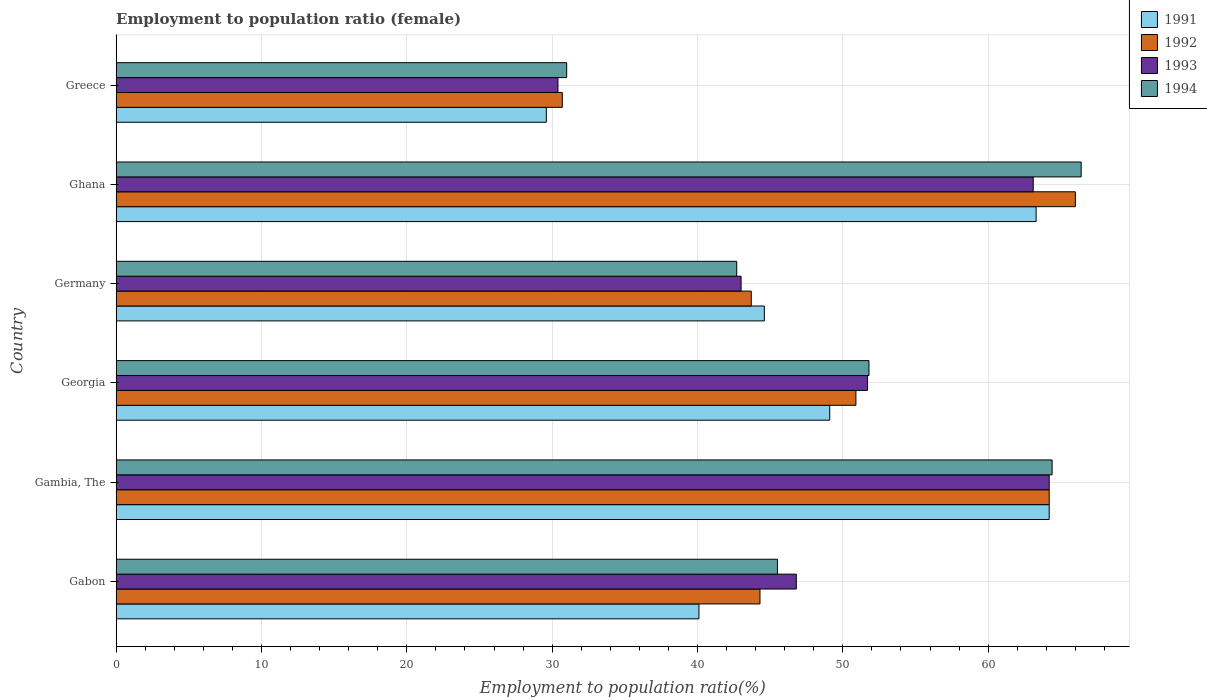How many different coloured bars are there?
Your answer should be very brief. 4. How many groups of bars are there?
Provide a short and direct response. 6. Are the number of bars per tick equal to the number of legend labels?
Your answer should be very brief. Yes. How many bars are there on the 2nd tick from the bottom?
Offer a terse response. 4. What is the label of the 5th group of bars from the top?
Give a very brief answer. Gambia, The. What is the employment to population ratio in 1994 in Georgia?
Give a very brief answer. 51.8. Across all countries, what is the maximum employment to population ratio in 1994?
Your answer should be compact. 66.4. Across all countries, what is the minimum employment to population ratio in 1993?
Your response must be concise. 30.4. In which country was the employment to population ratio in 1994 maximum?
Your answer should be very brief. Ghana. What is the total employment to population ratio in 1994 in the graph?
Offer a very short reply. 301.8. What is the difference between the employment to population ratio in 1992 in Gambia, The and that in Ghana?
Offer a terse response. -1.8. What is the difference between the employment to population ratio in 1993 in Georgia and the employment to population ratio in 1991 in Gambia, The?
Your answer should be compact. -12.5. What is the average employment to population ratio in 1993 per country?
Keep it short and to the point. 49.87. What is the difference between the employment to population ratio in 1993 and employment to population ratio in 1991 in Germany?
Your response must be concise. -1.6. In how many countries, is the employment to population ratio in 1994 greater than 14 %?
Keep it short and to the point. 6. What is the ratio of the employment to population ratio in 1993 in Gabon to that in Ghana?
Ensure brevity in your answer.  0.74. What is the difference between the highest and the second highest employment to population ratio in 1993?
Your answer should be very brief. 1.1. What is the difference between the highest and the lowest employment to population ratio in 1994?
Offer a terse response. 35.4. Is the sum of the employment to population ratio in 1994 in Gabon and Germany greater than the maximum employment to population ratio in 1991 across all countries?
Make the answer very short. Yes. What does the 2nd bar from the bottom in Gabon represents?
Keep it short and to the point. 1992. How many bars are there?
Offer a terse response. 24. Are all the bars in the graph horizontal?
Ensure brevity in your answer.  Yes. How many countries are there in the graph?
Provide a succinct answer. 6. Where does the legend appear in the graph?
Offer a very short reply. Top right. How are the legend labels stacked?
Your response must be concise. Vertical. What is the title of the graph?
Provide a succinct answer. Employment to population ratio (female). Does "1995" appear as one of the legend labels in the graph?
Ensure brevity in your answer.  No. What is the label or title of the X-axis?
Your answer should be very brief. Employment to population ratio(%). What is the Employment to population ratio(%) in 1991 in Gabon?
Give a very brief answer. 40.1. What is the Employment to population ratio(%) in 1992 in Gabon?
Make the answer very short. 44.3. What is the Employment to population ratio(%) of 1993 in Gabon?
Your answer should be compact. 46.8. What is the Employment to population ratio(%) in 1994 in Gabon?
Offer a terse response. 45.5. What is the Employment to population ratio(%) of 1991 in Gambia, The?
Your answer should be compact. 64.2. What is the Employment to population ratio(%) of 1992 in Gambia, The?
Provide a short and direct response. 64.2. What is the Employment to population ratio(%) of 1993 in Gambia, The?
Offer a very short reply. 64.2. What is the Employment to population ratio(%) in 1994 in Gambia, The?
Your answer should be compact. 64.4. What is the Employment to population ratio(%) of 1991 in Georgia?
Keep it short and to the point. 49.1. What is the Employment to population ratio(%) in 1992 in Georgia?
Provide a short and direct response. 50.9. What is the Employment to population ratio(%) of 1993 in Georgia?
Your answer should be compact. 51.7. What is the Employment to population ratio(%) in 1994 in Georgia?
Your answer should be compact. 51.8. What is the Employment to population ratio(%) of 1991 in Germany?
Offer a terse response. 44.6. What is the Employment to population ratio(%) in 1992 in Germany?
Provide a short and direct response. 43.7. What is the Employment to population ratio(%) in 1994 in Germany?
Give a very brief answer. 42.7. What is the Employment to population ratio(%) of 1991 in Ghana?
Your answer should be very brief. 63.3. What is the Employment to population ratio(%) of 1993 in Ghana?
Keep it short and to the point. 63.1. What is the Employment to population ratio(%) of 1994 in Ghana?
Your answer should be very brief. 66.4. What is the Employment to population ratio(%) of 1991 in Greece?
Your response must be concise. 29.6. What is the Employment to population ratio(%) of 1992 in Greece?
Your response must be concise. 30.7. What is the Employment to population ratio(%) in 1993 in Greece?
Provide a succinct answer. 30.4. Across all countries, what is the maximum Employment to population ratio(%) of 1991?
Provide a short and direct response. 64.2. Across all countries, what is the maximum Employment to population ratio(%) in 1993?
Your response must be concise. 64.2. Across all countries, what is the maximum Employment to population ratio(%) in 1994?
Ensure brevity in your answer.  66.4. Across all countries, what is the minimum Employment to population ratio(%) in 1991?
Provide a short and direct response. 29.6. Across all countries, what is the minimum Employment to population ratio(%) in 1992?
Ensure brevity in your answer.  30.7. Across all countries, what is the minimum Employment to population ratio(%) of 1993?
Your response must be concise. 30.4. What is the total Employment to population ratio(%) of 1991 in the graph?
Keep it short and to the point. 290.9. What is the total Employment to population ratio(%) of 1992 in the graph?
Your response must be concise. 299.8. What is the total Employment to population ratio(%) of 1993 in the graph?
Keep it short and to the point. 299.2. What is the total Employment to population ratio(%) of 1994 in the graph?
Make the answer very short. 301.8. What is the difference between the Employment to population ratio(%) in 1991 in Gabon and that in Gambia, The?
Make the answer very short. -24.1. What is the difference between the Employment to population ratio(%) of 1992 in Gabon and that in Gambia, The?
Keep it short and to the point. -19.9. What is the difference between the Employment to population ratio(%) in 1993 in Gabon and that in Gambia, The?
Provide a short and direct response. -17.4. What is the difference between the Employment to population ratio(%) of 1994 in Gabon and that in Gambia, The?
Give a very brief answer. -18.9. What is the difference between the Employment to population ratio(%) of 1993 in Gabon and that in Georgia?
Your response must be concise. -4.9. What is the difference between the Employment to population ratio(%) in 1994 in Gabon and that in Georgia?
Your answer should be compact. -6.3. What is the difference between the Employment to population ratio(%) in 1991 in Gabon and that in Germany?
Ensure brevity in your answer.  -4.5. What is the difference between the Employment to population ratio(%) in 1993 in Gabon and that in Germany?
Keep it short and to the point. 3.8. What is the difference between the Employment to population ratio(%) in 1994 in Gabon and that in Germany?
Your response must be concise. 2.8. What is the difference between the Employment to population ratio(%) in 1991 in Gabon and that in Ghana?
Your answer should be very brief. -23.2. What is the difference between the Employment to population ratio(%) of 1992 in Gabon and that in Ghana?
Your answer should be very brief. -21.7. What is the difference between the Employment to population ratio(%) of 1993 in Gabon and that in Ghana?
Offer a terse response. -16.3. What is the difference between the Employment to population ratio(%) of 1994 in Gabon and that in Ghana?
Your answer should be compact. -20.9. What is the difference between the Employment to population ratio(%) of 1993 in Gabon and that in Greece?
Your answer should be compact. 16.4. What is the difference between the Employment to population ratio(%) in 1994 in Gabon and that in Greece?
Offer a terse response. 14.5. What is the difference between the Employment to population ratio(%) of 1993 in Gambia, The and that in Georgia?
Provide a succinct answer. 12.5. What is the difference between the Employment to population ratio(%) in 1994 in Gambia, The and that in Georgia?
Keep it short and to the point. 12.6. What is the difference between the Employment to population ratio(%) of 1991 in Gambia, The and that in Germany?
Provide a succinct answer. 19.6. What is the difference between the Employment to population ratio(%) in 1992 in Gambia, The and that in Germany?
Offer a very short reply. 20.5. What is the difference between the Employment to population ratio(%) of 1993 in Gambia, The and that in Germany?
Keep it short and to the point. 21.2. What is the difference between the Employment to population ratio(%) in 1994 in Gambia, The and that in Germany?
Ensure brevity in your answer.  21.7. What is the difference between the Employment to population ratio(%) in 1991 in Gambia, The and that in Ghana?
Your response must be concise. 0.9. What is the difference between the Employment to population ratio(%) in 1991 in Gambia, The and that in Greece?
Ensure brevity in your answer.  34.6. What is the difference between the Employment to population ratio(%) of 1992 in Gambia, The and that in Greece?
Provide a short and direct response. 33.5. What is the difference between the Employment to population ratio(%) of 1993 in Gambia, The and that in Greece?
Offer a terse response. 33.8. What is the difference between the Employment to population ratio(%) in 1994 in Gambia, The and that in Greece?
Give a very brief answer. 33.4. What is the difference between the Employment to population ratio(%) in 1991 in Georgia and that in Germany?
Provide a short and direct response. 4.5. What is the difference between the Employment to population ratio(%) of 1992 in Georgia and that in Germany?
Ensure brevity in your answer.  7.2. What is the difference between the Employment to population ratio(%) of 1991 in Georgia and that in Ghana?
Ensure brevity in your answer.  -14.2. What is the difference between the Employment to population ratio(%) in 1992 in Georgia and that in Ghana?
Ensure brevity in your answer.  -15.1. What is the difference between the Employment to population ratio(%) in 1994 in Georgia and that in Ghana?
Your answer should be compact. -14.6. What is the difference between the Employment to population ratio(%) in 1991 in Georgia and that in Greece?
Provide a short and direct response. 19.5. What is the difference between the Employment to population ratio(%) of 1992 in Georgia and that in Greece?
Give a very brief answer. 20.2. What is the difference between the Employment to population ratio(%) in 1993 in Georgia and that in Greece?
Keep it short and to the point. 21.3. What is the difference between the Employment to population ratio(%) in 1994 in Georgia and that in Greece?
Ensure brevity in your answer.  20.8. What is the difference between the Employment to population ratio(%) in 1991 in Germany and that in Ghana?
Keep it short and to the point. -18.7. What is the difference between the Employment to population ratio(%) of 1992 in Germany and that in Ghana?
Provide a succinct answer. -22.3. What is the difference between the Employment to population ratio(%) in 1993 in Germany and that in Ghana?
Offer a terse response. -20.1. What is the difference between the Employment to population ratio(%) of 1994 in Germany and that in Ghana?
Your response must be concise. -23.7. What is the difference between the Employment to population ratio(%) of 1991 in Germany and that in Greece?
Keep it short and to the point. 15. What is the difference between the Employment to population ratio(%) of 1993 in Germany and that in Greece?
Your response must be concise. 12.6. What is the difference between the Employment to population ratio(%) in 1991 in Ghana and that in Greece?
Offer a terse response. 33.7. What is the difference between the Employment to population ratio(%) in 1992 in Ghana and that in Greece?
Make the answer very short. 35.3. What is the difference between the Employment to population ratio(%) in 1993 in Ghana and that in Greece?
Give a very brief answer. 32.7. What is the difference between the Employment to population ratio(%) in 1994 in Ghana and that in Greece?
Make the answer very short. 35.4. What is the difference between the Employment to population ratio(%) of 1991 in Gabon and the Employment to population ratio(%) of 1992 in Gambia, The?
Keep it short and to the point. -24.1. What is the difference between the Employment to population ratio(%) in 1991 in Gabon and the Employment to population ratio(%) in 1993 in Gambia, The?
Your answer should be compact. -24.1. What is the difference between the Employment to population ratio(%) of 1991 in Gabon and the Employment to population ratio(%) of 1994 in Gambia, The?
Provide a short and direct response. -24.3. What is the difference between the Employment to population ratio(%) in 1992 in Gabon and the Employment to population ratio(%) in 1993 in Gambia, The?
Your answer should be very brief. -19.9. What is the difference between the Employment to population ratio(%) in 1992 in Gabon and the Employment to population ratio(%) in 1994 in Gambia, The?
Make the answer very short. -20.1. What is the difference between the Employment to population ratio(%) of 1993 in Gabon and the Employment to population ratio(%) of 1994 in Gambia, The?
Your answer should be compact. -17.6. What is the difference between the Employment to population ratio(%) in 1991 in Gabon and the Employment to population ratio(%) in 1993 in Georgia?
Provide a succinct answer. -11.6. What is the difference between the Employment to population ratio(%) in 1991 in Gabon and the Employment to population ratio(%) in 1994 in Georgia?
Ensure brevity in your answer.  -11.7. What is the difference between the Employment to population ratio(%) in 1992 in Gabon and the Employment to population ratio(%) in 1993 in Georgia?
Offer a terse response. -7.4. What is the difference between the Employment to population ratio(%) of 1991 in Gabon and the Employment to population ratio(%) of 1993 in Germany?
Give a very brief answer. -2.9. What is the difference between the Employment to population ratio(%) in 1991 in Gabon and the Employment to population ratio(%) in 1994 in Germany?
Make the answer very short. -2.6. What is the difference between the Employment to population ratio(%) in 1992 in Gabon and the Employment to population ratio(%) in 1993 in Germany?
Ensure brevity in your answer.  1.3. What is the difference between the Employment to population ratio(%) in 1992 in Gabon and the Employment to population ratio(%) in 1994 in Germany?
Offer a very short reply. 1.6. What is the difference between the Employment to population ratio(%) in 1991 in Gabon and the Employment to population ratio(%) in 1992 in Ghana?
Ensure brevity in your answer.  -25.9. What is the difference between the Employment to population ratio(%) of 1991 in Gabon and the Employment to population ratio(%) of 1993 in Ghana?
Provide a succinct answer. -23. What is the difference between the Employment to population ratio(%) in 1991 in Gabon and the Employment to population ratio(%) in 1994 in Ghana?
Your response must be concise. -26.3. What is the difference between the Employment to population ratio(%) of 1992 in Gabon and the Employment to population ratio(%) of 1993 in Ghana?
Give a very brief answer. -18.8. What is the difference between the Employment to population ratio(%) of 1992 in Gabon and the Employment to population ratio(%) of 1994 in Ghana?
Give a very brief answer. -22.1. What is the difference between the Employment to population ratio(%) in 1993 in Gabon and the Employment to population ratio(%) in 1994 in Ghana?
Your response must be concise. -19.6. What is the difference between the Employment to population ratio(%) of 1991 in Gabon and the Employment to population ratio(%) of 1992 in Greece?
Give a very brief answer. 9.4. What is the difference between the Employment to population ratio(%) in 1992 in Gabon and the Employment to population ratio(%) in 1993 in Greece?
Ensure brevity in your answer.  13.9. What is the difference between the Employment to population ratio(%) in 1993 in Gabon and the Employment to population ratio(%) in 1994 in Greece?
Provide a succinct answer. 15.8. What is the difference between the Employment to population ratio(%) in 1991 in Gambia, The and the Employment to population ratio(%) in 1992 in Georgia?
Offer a terse response. 13.3. What is the difference between the Employment to population ratio(%) of 1991 in Gambia, The and the Employment to population ratio(%) of 1993 in Georgia?
Offer a terse response. 12.5. What is the difference between the Employment to population ratio(%) of 1991 in Gambia, The and the Employment to population ratio(%) of 1994 in Georgia?
Give a very brief answer. 12.4. What is the difference between the Employment to population ratio(%) in 1992 in Gambia, The and the Employment to population ratio(%) in 1993 in Georgia?
Your response must be concise. 12.5. What is the difference between the Employment to population ratio(%) in 1991 in Gambia, The and the Employment to population ratio(%) in 1993 in Germany?
Provide a succinct answer. 21.2. What is the difference between the Employment to population ratio(%) of 1992 in Gambia, The and the Employment to population ratio(%) of 1993 in Germany?
Give a very brief answer. 21.2. What is the difference between the Employment to population ratio(%) of 1993 in Gambia, The and the Employment to population ratio(%) of 1994 in Germany?
Your response must be concise. 21.5. What is the difference between the Employment to population ratio(%) in 1991 in Gambia, The and the Employment to population ratio(%) in 1994 in Ghana?
Provide a succinct answer. -2.2. What is the difference between the Employment to population ratio(%) of 1992 in Gambia, The and the Employment to population ratio(%) of 1993 in Ghana?
Ensure brevity in your answer.  1.1. What is the difference between the Employment to population ratio(%) of 1993 in Gambia, The and the Employment to population ratio(%) of 1994 in Ghana?
Your answer should be compact. -2.2. What is the difference between the Employment to population ratio(%) in 1991 in Gambia, The and the Employment to population ratio(%) in 1992 in Greece?
Your response must be concise. 33.5. What is the difference between the Employment to population ratio(%) in 1991 in Gambia, The and the Employment to population ratio(%) in 1993 in Greece?
Ensure brevity in your answer.  33.8. What is the difference between the Employment to population ratio(%) in 1991 in Gambia, The and the Employment to population ratio(%) in 1994 in Greece?
Your answer should be compact. 33.2. What is the difference between the Employment to population ratio(%) in 1992 in Gambia, The and the Employment to population ratio(%) in 1993 in Greece?
Provide a succinct answer. 33.8. What is the difference between the Employment to population ratio(%) of 1992 in Gambia, The and the Employment to population ratio(%) of 1994 in Greece?
Ensure brevity in your answer.  33.2. What is the difference between the Employment to population ratio(%) in 1993 in Gambia, The and the Employment to population ratio(%) in 1994 in Greece?
Your response must be concise. 33.2. What is the difference between the Employment to population ratio(%) of 1991 in Georgia and the Employment to population ratio(%) of 1993 in Germany?
Keep it short and to the point. 6.1. What is the difference between the Employment to population ratio(%) of 1992 in Georgia and the Employment to population ratio(%) of 1993 in Germany?
Your answer should be compact. 7.9. What is the difference between the Employment to population ratio(%) in 1993 in Georgia and the Employment to population ratio(%) in 1994 in Germany?
Keep it short and to the point. 9. What is the difference between the Employment to population ratio(%) in 1991 in Georgia and the Employment to population ratio(%) in 1992 in Ghana?
Your answer should be compact. -16.9. What is the difference between the Employment to population ratio(%) in 1991 in Georgia and the Employment to population ratio(%) in 1993 in Ghana?
Provide a short and direct response. -14. What is the difference between the Employment to population ratio(%) of 1991 in Georgia and the Employment to population ratio(%) of 1994 in Ghana?
Ensure brevity in your answer.  -17.3. What is the difference between the Employment to population ratio(%) in 1992 in Georgia and the Employment to population ratio(%) in 1993 in Ghana?
Offer a terse response. -12.2. What is the difference between the Employment to population ratio(%) of 1992 in Georgia and the Employment to population ratio(%) of 1994 in Ghana?
Your answer should be very brief. -15.5. What is the difference between the Employment to population ratio(%) in 1993 in Georgia and the Employment to population ratio(%) in 1994 in Ghana?
Give a very brief answer. -14.7. What is the difference between the Employment to population ratio(%) in 1991 in Georgia and the Employment to population ratio(%) in 1993 in Greece?
Your response must be concise. 18.7. What is the difference between the Employment to population ratio(%) in 1991 in Georgia and the Employment to population ratio(%) in 1994 in Greece?
Your answer should be compact. 18.1. What is the difference between the Employment to population ratio(%) in 1992 in Georgia and the Employment to population ratio(%) in 1993 in Greece?
Make the answer very short. 20.5. What is the difference between the Employment to population ratio(%) in 1992 in Georgia and the Employment to population ratio(%) in 1994 in Greece?
Your response must be concise. 19.9. What is the difference between the Employment to population ratio(%) of 1993 in Georgia and the Employment to population ratio(%) of 1994 in Greece?
Your answer should be compact. 20.7. What is the difference between the Employment to population ratio(%) in 1991 in Germany and the Employment to population ratio(%) in 1992 in Ghana?
Provide a short and direct response. -21.4. What is the difference between the Employment to population ratio(%) in 1991 in Germany and the Employment to population ratio(%) in 1993 in Ghana?
Ensure brevity in your answer.  -18.5. What is the difference between the Employment to population ratio(%) in 1991 in Germany and the Employment to population ratio(%) in 1994 in Ghana?
Offer a terse response. -21.8. What is the difference between the Employment to population ratio(%) in 1992 in Germany and the Employment to population ratio(%) in 1993 in Ghana?
Ensure brevity in your answer.  -19.4. What is the difference between the Employment to population ratio(%) in 1992 in Germany and the Employment to population ratio(%) in 1994 in Ghana?
Give a very brief answer. -22.7. What is the difference between the Employment to population ratio(%) in 1993 in Germany and the Employment to population ratio(%) in 1994 in Ghana?
Provide a short and direct response. -23.4. What is the difference between the Employment to population ratio(%) of 1992 in Germany and the Employment to population ratio(%) of 1994 in Greece?
Keep it short and to the point. 12.7. What is the difference between the Employment to population ratio(%) of 1991 in Ghana and the Employment to population ratio(%) of 1992 in Greece?
Provide a succinct answer. 32.6. What is the difference between the Employment to population ratio(%) in 1991 in Ghana and the Employment to population ratio(%) in 1993 in Greece?
Your answer should be very brief. 32.9. What is the difference between the Employment to population ratio(%) in 1991 in Ghana and the Employment to population ratio(%) in 1994 in Greece?
Your answer should be compact. 32.3. What is the difference between the Employment to population ratio(%) of 1992 in Ghana and the Employment to population ratio(%) of 1993 in Greece?
Keep it short and to the point. 35.6. What is the difference between the Employment to population ratio(%) of 1993 in Ghana and the Employment to population ratio(%) of 1994 in Greece?
Provide a short and direct response. 32.1. What is the average Employment to population ratio(%) of 1991 per country?
Give a very brief answer. 48.48. What is the average Employment to population ratio(%) in 1992 per country?
Give a very brief answer. 49.97. What is the average Employment to population ratio(%) of 1993 per country?
Keep it short and to the point. 49.87. What is the average Employment to population ratio(%) of 1994 per country?
Offer a terse response. 50.3. What is the difference between the Employment to population ratio(%) in 1991 and Employment to population ratio(%) in 1992 in Gabon?
Ensure brevity in your answer.  -4.2. What is the difference between the Employment to population ratio(%) of 1991 and Employment to population ratio(%) of 1993 in Gabon?
Your response must be concise. -6.7. What is the difference between the Employment to population ratio(%) of 1992 and Employment to population ratio(%) of 1993 in Gabon?
Keep it short and to the point. -2.5. What is the difference between the Employment to population ratio(%) in 1993 and Employment to population ratio(%) in 1994 in Gabon?
Give a very brief answer. 1.3. What is the difference between the Employment to population ratio(%) in 1991 and Employment to population ratio(%) in 1992 in Gambia, The?
Make the answer very short. 0. What is the difference between the Employment to population ratio(%) of 1992 and Employment to population ratio(%) of 1994 in Gambia, The?
Provide a short and direct response. -0.2. What is the difference between the Employment to population ratio(%) in 1993 and Employment to population ratio(%) in 1994 in Gambia, The?
Give a very brief answer. -0.2. What is the difference between the Employment to population ratio(%) in 1991 and Employment to population ratio(%) in 1994 in Georgia?
Keep it short and to the point. -2.7. What is the difference between the Employment to population ratio(%) of 1992 and Employment to population ratio(%) of 1993 in Georgia?
Keep it short and to the point. -0.8. What is the difference between the Employment to population ratio(%) of 1992 and Employment to population ratio(%) of 1994 in Georgia?
Provide a short and direct response. -0.9. What is the difference between the Employment to population ratio(%) of 1993 and Employment to population ratio(%) of 1994 in Georgia?
Keep it short and to the point. -0.1. What is the difference between the Employment to population ratio(%) in 1991 and Employment to population ratio(%) in 1992 in Germany?
Ensure brevity in your answer.  0.9. What is the difference between the Employment to population ratio(%) of 1991 and Employment to population ratio(%) of 1993 in Germany?
Keep it short and to the point. 1.6. What is the difference between the Employment to population ratio(%) of 1991 and Employment to population ratio(%) of 1994 in Germany?
Ensure brevity in your answer.  1.9. What is the difference between the Employment to population ratio(%) in 1992 and Employment to population ratio(%) in 1994 in Germany?
Keep it short and to the point. 1. What is the difference between the Employment to population ratio(%) of 1991 and Employment to population ratio(%) of 1992 in Ghana?
Offer a very short reply. -2.7. What is the difference between the Employment to population ratio(%) in 1991 and Employment to population ratio(%) in 1994 in Ghana?
Your response must be concise. -3.1. What is the difference between the Employment to population ratio(%) of 1993 and Employment to population ratio(%) of 1994 in Greece?
Make the answer very short. -0.6. What is the ratio of the Employment to population ratio(%) in 1991 in Gabon to that in Gambia, The?
Your response must be concise. 0.62. What is the ratio of the Employment to population ratio(%) of 1992 in Gabon to that in Gambia, The?
Keep it short and to the point. 0.69. What is the ratio of the Employment to population ratio(%) in 1993 in Gabon to that in Gambia, The?
Offer a very short reply. 0.73. What is the ratio of the Employment to population ratio(%) in 1994 in Gabon to that in Gambia, The?
Keep it short and to the point. 0.71. What is the ratio of the Employment to population ratio(%) of 1991 in Gabon to that in Georgia?
Your response must be concise. 0.82. What is the ratio of the Employment to population ratio(%) in 1992 in Gabon to that in Georgia?
Your answer should be compact. 0.87. What is the ratio of the Employment to population ratio(%) in 1993 in Gabon to that in Georgia?
Make the answer very short. 0.91. What is the ratio of the Employment to population ratio(%) of 1994 in Gabon to that in Georgia?
Provide a short and direct response. 0.88. What is the ratio of the Employment to population ratio(%) of 1991 in Gabon to that in Germany?
Offer a very short reply. 0.9. What is the ratio of the Employment to population ratio(%) in 1992 in Gabon to that in Germany?
Give a very brief answer. 1.01. What is the ratio of the Employment to population ratio(%) of 1993 in Gabon to that in Germany?
Keep it short and to the point. 1.09. What is the ratio of the Employment to population ratio(%) in 1994 in Gabon to that in Germany?
Give a very brief answer. 1.07. What is the ratio of the Employment to population ratio(%) in 1991 in Gabon to that in Ghana?
Offer a terse response. 0.63. What is the ratio of the Employment to population ratio(%) of 1992 in Gabon to that in Ghana?
Provide a short and direct response. 0.67. What is the ratio of the Employment to population ratio(%) of 1993 in Gabon to that in Ghana?
Offer a very short reply. 0.74. What is the ratio of the Employment to population ratio(%) in 1994 in Gabon to that in Ghana?
Provide a succinct answer. 0.69. What is the ratio of the Employment to population ratio(%) of 1991 in Gabon to that in Greece?
Your answer should be very brief. 1.35. What is the ratio of the Employment to population ratio(%) in 1992 in Gabon to that in Greece?
Your answer should be very brief. 1.44. What is the ratio of the Employment to population ratio(%) in 1993 in Gabon to that in Greece?
Offer a terse response. 1.54. What is the ratio of the Employment to population ratio(%) in 1994 in Gabon to that in Greece?
Provide a succinct answer. 1.47. What is the ratio of the Employment to population ratio(%) of 1991 in Gambia, The to that in Georgia?
Your answer should be very brief. 1.31. What is the ratio of the Employment to population ratio(%) of 1992 in Gambia, The to that in Georgia?
Your response must be concise. 1.26. What is the ratio of the Employment to population ratio(%) in 1993 in Gambia, The to that in Georgia?
Give a very brief answer. 1.24. What is the ratio of the Employment to population ratio(%) in 1994 in Gambia, The to that in Georgia?
Offer a very short reply. 1.24. What is the ratio of the Employment to population ratio(%) in 1991 in Gambia, The to that in Germany?
Offer a very short reply. 1.44. What is the ratio of the Employment to population ratio(%) of 1992 in Gambia, The to that in Germany?
Provide a succinct answer. 1.47. What is the ratio of the Employment to population ratio(%) in 1993 in Gambia, The to that in Germany?
Provide a succinct answer. 1.49. What is the ratio of the Employment to population ratio(%) of 1994 in Gambia, The to that in Germany?
Offer a terse response. 1.51. What is the ratio of the Employment to population ratio(%) of 1991 in Gambia, The to that in Ghana?
Your answer should be compact. 1.01. What is the ratio of the Employment to population ratio(%) of 1992 in Gambia, The to that in Ghana?
Your response must be concise. 0.97. What is the ratio of the Employment to population ratio(%) in 1993 in Gambia, The to that in Ghana?
Your answer should be very brief. 1.02. What is the ratio of the Employment to population ratio(%) in 1994 in Gambia, The to that in Ghana?
Give a very brief answer. 0.97. What is the ratio of the Employment to population ratio(%) in 1991 in Gambia, The to that in Greece?
Keep it short and to the point. 2.17. What is the ratio of the Employment to population ratio(%) in 1992 in Gambia, The to that in Greece?
Provide a succinct answer. 2.09. What is the ratio of the Employment to population ratio(%) of 1993 in Gambia, The to that in Greece?
Your response must be concise. 2.11. What is the ratio of the Employment to population ratio(%) of 1994 in Gambia, The to that in Greece?
Make the answer very short. 2.08. What is the ratio of the Employment to population ratio(%) of 1991 in Georgia to that in Germany?
Make the answer very short. 1.1. What is the ratio of the Employment to population ratio(%) in 1992 in Georgia to that in Germany?
Your answer should be compact. 1.16. What is the ratio of the Employment to population ratio(%) in 1993 in Georgia to that in Germany?
Your answer should be compact. 1.2. What is the ratio of the Employment to population ratio(%) in 1994 in Georgia to that in Germany?
Offer a very short reply. 1.21. What is the ratio of the Employment to population ratio(%) of 1991 in Georgia to that in Ghana?
Your response must be concise. 0.78. What is the ratio of the Employment to population ratio(%) in 1992 in Georgia to that in Ghana?
Offer a terse response. 0.77. What is the ratio of the Employment to population ratio(%) of 1993 in Georgia to that in Ghana?
Make the answer very short. 0.82. What is the ratio of the Employment to population ratio(%) in 1994 in Georgia to that in Ghana?
Provide a short and direct response. 0.78. What is the ratio of the Employment to population ratio(%) in 1991 in Georgia to that in Greece?
Make the answer very short. 1.66. What is the ratio of the Employment to population ratio(%) in 1992 in Georgia to that in Greece?
Your answer should be compact. 1.66. What is the ratio of the Employment to population ratio(%) of 1993 in Georgia to that in Greece?
Keep it short and to the point. 1.7. What is the ratio of the Employment to population ratio(%) of 1994 in Georgia to that in Greece?
Make the answer very short. 1.67. What is the ratio of the Employment to population ratio(%) of 1991 in Germany to that in Ghana?
Your response must be concise. 0.7. What is the ratio of the Employment to population ratio(%) in 1992 in Germany to that in Ghana?
Provide a short and direct response. 0.66. What is the ratio of the Employment to population ratio(%) of 1993 in Germany to that in Ghana?
Offer a very short reply. 0.68. What is the ratio of the Employment to population ratio(%) of 1994 in Germany to that in Ghana?
Keep it short and to the point. 0.64. What is the ratio of the Employment to population ratio(%) in 1991 in Germany to that in Greece?
Ensure brevity in your answer.  1.51. What is the ratio of the Employment to population ratio(%) in 1992 in Germany to that in Greece?
Provide a short and direct response. 1.42. What is the ratio of the Employment to population ratio(%) in 1993 in Germany to that in Greece?
Your response must be concise. 1.41. What is the ratio of the Employment to population ratio(%) of 1994 in Germany to that in Greece?
Your answer should be compact. 1.38. What is the ratio of the Employment to population ratio(%) in 1991 in Ghana to that in Greece?
Provide a short and direct response. 2.14. What is the ratio of the Employment to population ratio(%) in 1992 in Ghana to that in Greece?
Provide a succinct answer. 2.15. What is the ratio of the Employment to population ratio(%) in 1993 in Ghana to that in Greece?
Keep it short and to the point. 2.08. What is the ratio of the Employment to population ratio(%) in 1994 in Ghana to that in Greece?
Offer a terse response. 2.14. What is the difference between the highest and the second highest Employment to population ratio(%) in 1991?
Ensure brevity in your answer.  0.9. What is the difference between the highest and the second highest Employment to population ratio(%) in 1992?
Keep it short and to the point. 1.8. What is the difference between the highest and the second highest Employment to population ratio(%) in 1993?
Make the answer very short. 1.1. What is the difference between the highest and the lowest Employment to population ratio(%) of 1991?
Give a very brief answer. 34.6. What is the difference between the highest and the lowest Employment to population ratio(%) in 1992?
Your response must be concise. 35.3. What is the difference between the highest and the lowest Employment to population ratio(%) in 1993?
Offer a terse response. 33.8. What is the difference between the highest and the lowest Employment to population ratio(%) in 1994?
Keep it short and to the point. 35.4. 